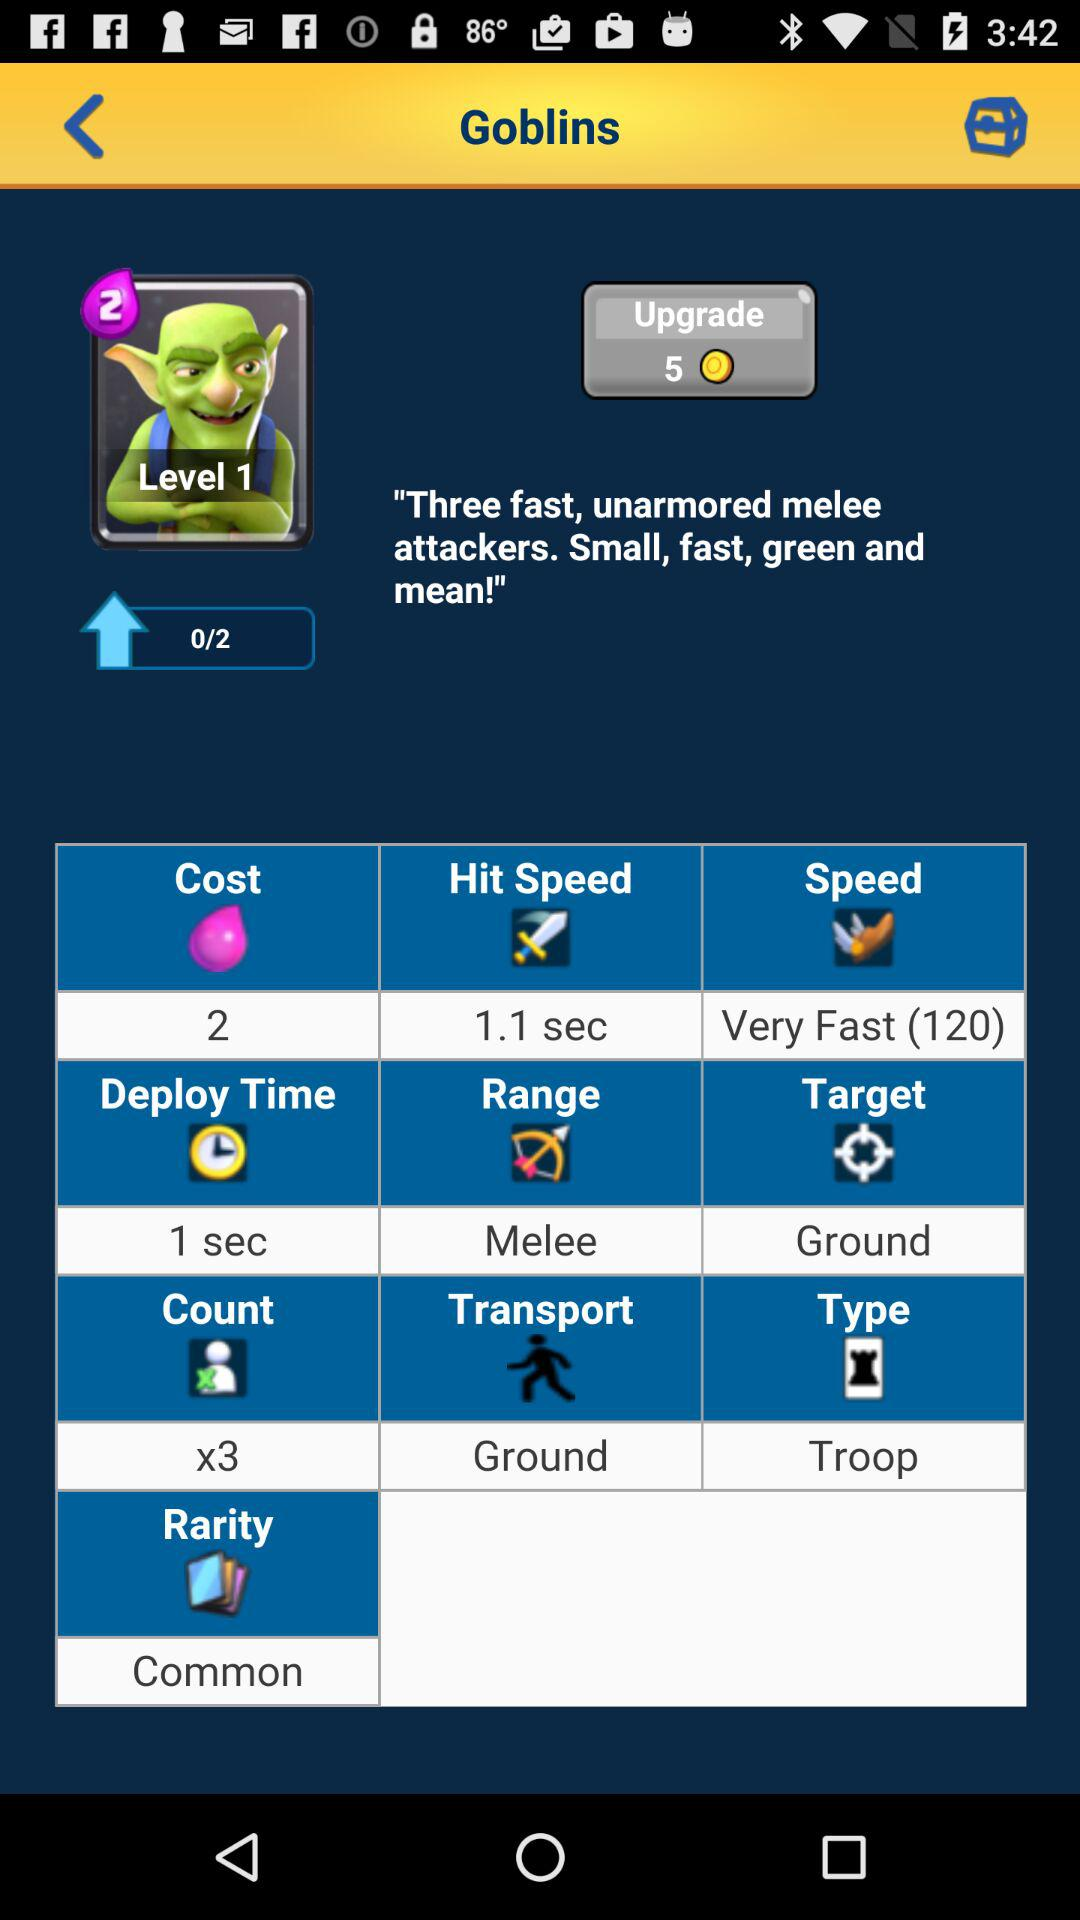What is the app name?
When the provided information is insufficient, respond with <no answer>. <no answer> 